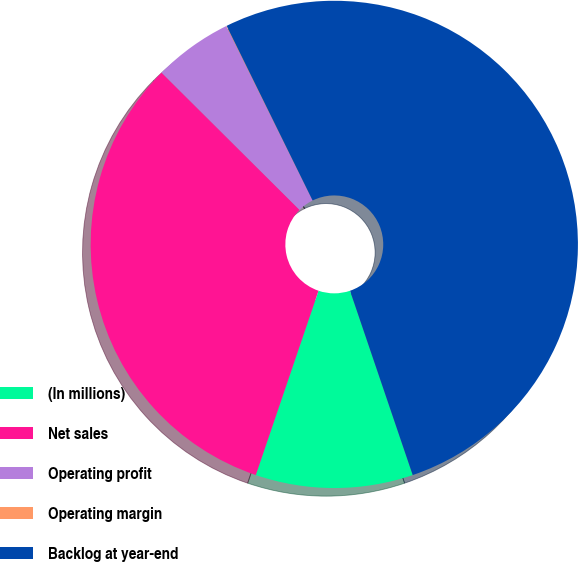<chart> <loc_0><loc_0><loc_500><loc_500><pie_chart><fcel>(In millions)<fcel>Net sales<fcel>Operating profit<fcel>Operating margin<fcel>Backlog at year-end<nl><fcel>10.44%<fcel>32.24%<fcel>5.23%<fcel>0.03%<fcel>52.07%<nl></chart> 